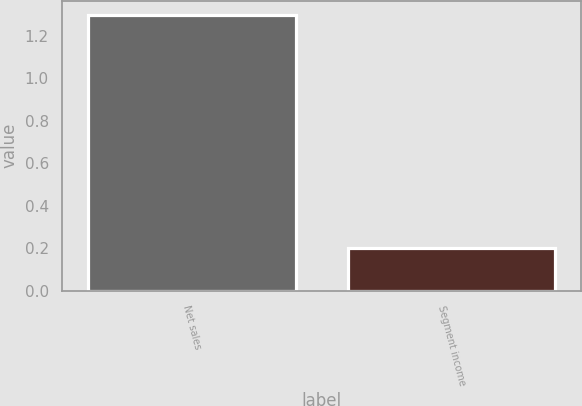<chart> <loc_0><loc_0><loc_500><loc_500><bar_chart><fcel>Net sales<fcel>Segment income<nl><fcel>1.3<fcel>0.2<nl></chart> 